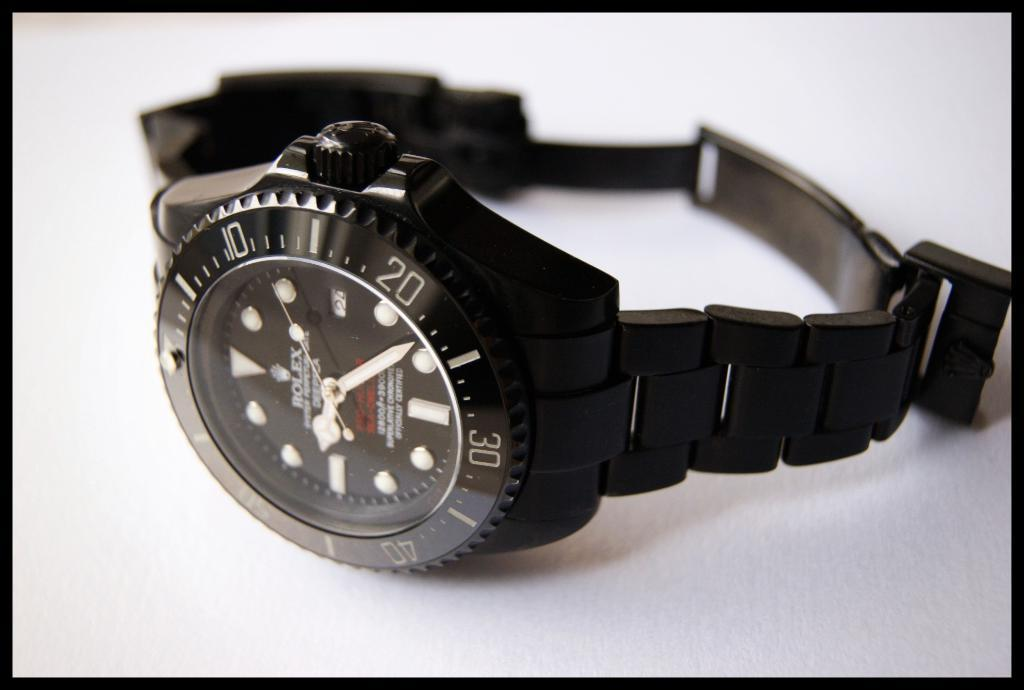<image>
Describe the image concisely. A black watch made by Rolex lying on its side. 